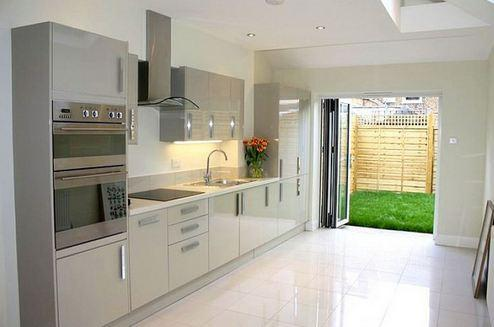What is the green object on top of the counter to the right of the sink?

Choices:
A) fern
B) flowers
C) grass
D) tree flowers 